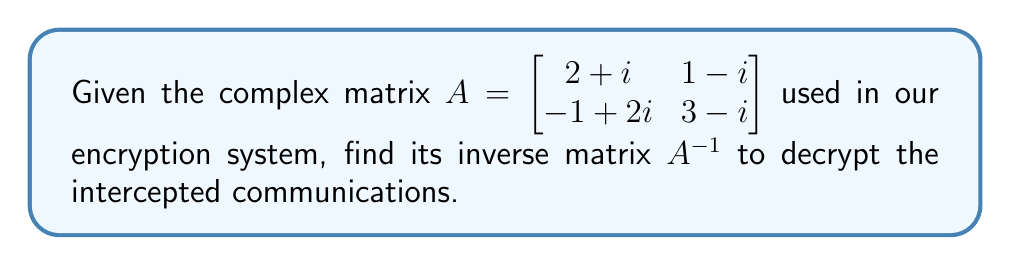Can you solve this math problem? To find the inverse of a 2x2 complex matrix, we can use the following steps:

1. Calculate the determinant of A:
   $$\det(A) = (2+i)(3-i) - (1-i)(-1+2i)$$
   $$= (6-2i+3i-i^2) - (-1+2i-i+2i^2)$$
   $$= (6+i+1) - (-1+i-2)$$
   $$= 8 - (-3) = 11$$

2. Find the adjugate matrix:
   $$adj(A) = \begin{bmatrix} 3-i & -(1-i) \\ -(-1+2i) & 2+i \end{bmatrix}$$
   $$= \begin{bmatrix} 3-i & -1+i \\ 1-2i & 2+i \end{bmatrix}$$

3. Calculate the inverse using the formula $A^{-1} = \frac{1}{\det(A)} \cdot adj(A)$:
   $$A^{-1} = \frac{1}{11} \begin{bmatrix} 3-i & -1+i \\ 1-2i & 2+i \end{bmatrix}$$

4. Simplify the fractions:
   $$A^{-1} = \begin{bmatrix} \frac{3}{11}-\frac{i}{11} & -\frac{1}{11}+\frac{i}{11} \\ \frac{1}{11}-\frac{2i}{11} & \frac{2}{11}+\frac{i}{11} \end{bmatrix}$$
Answer: $$A^{-1} = \begin{bmatrix} \frac{3-i}{11} & \frac{-1+i}{11} \\ \frac{1-2i}{11} & \frac{2+i}{11} \end{bmatrix}$$ 